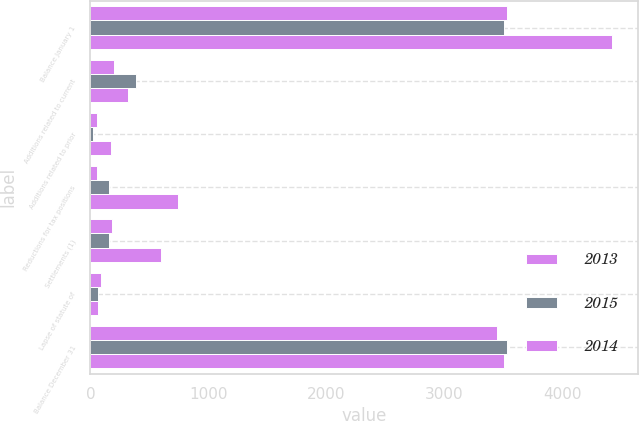Convert chart. <chart><loc_0><loc_0><loc_500><loc_500><stacked_bar_chart><ecel><fcel>Balance January 1<fcel>Additions related to current<fcel>Additions related to prior<fcel>Reductions for tax positions<fcel>Settlements (1)<fcel>Lapse of statute of<fcel>Balance December 31<nl><fcel>2013<fcel>3534<fcel>198<fcel>53<fcel>59<fcel>184<fcel>94<fcel>3448<nl><fcel>2015<fcel>3503<fcel>389<fcel>23<fcel>156<fcel>161<fcel>64<fcel>3534<nl><fcel>2014<fcel>4425<fcel>320<fcel>177<fcel>747<fcel>603<fcel>69<fcel>3503<nl></chart> 